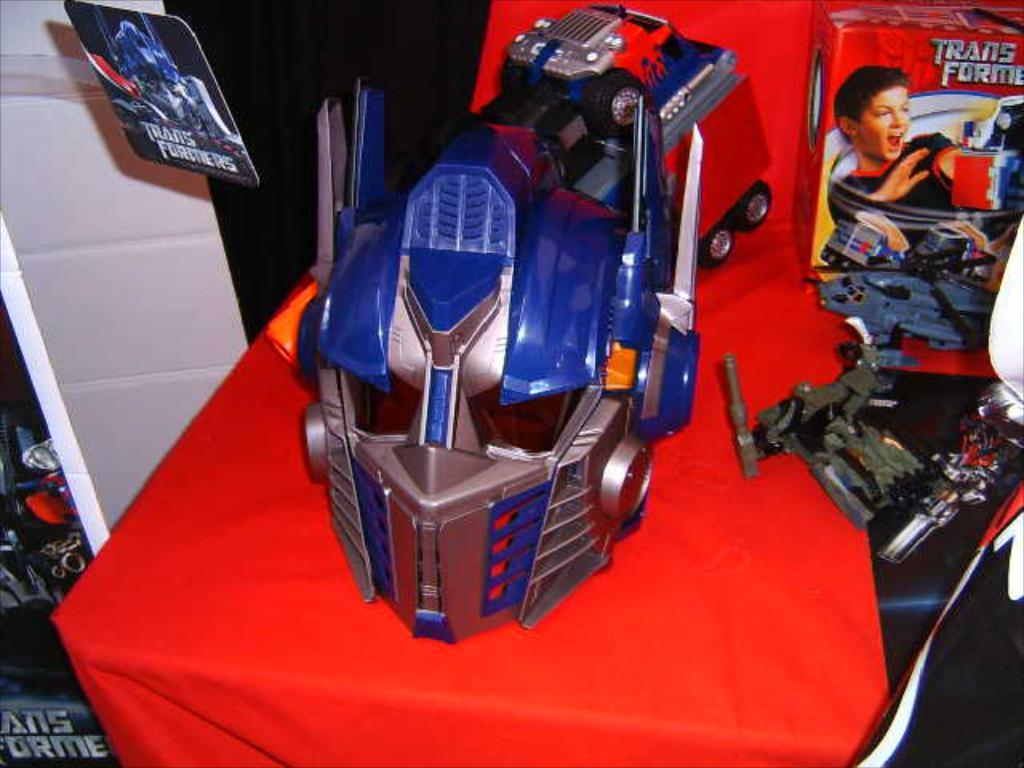<image>
Describe the image concisely. Robot helmet on a table with the word Transformers by it. 